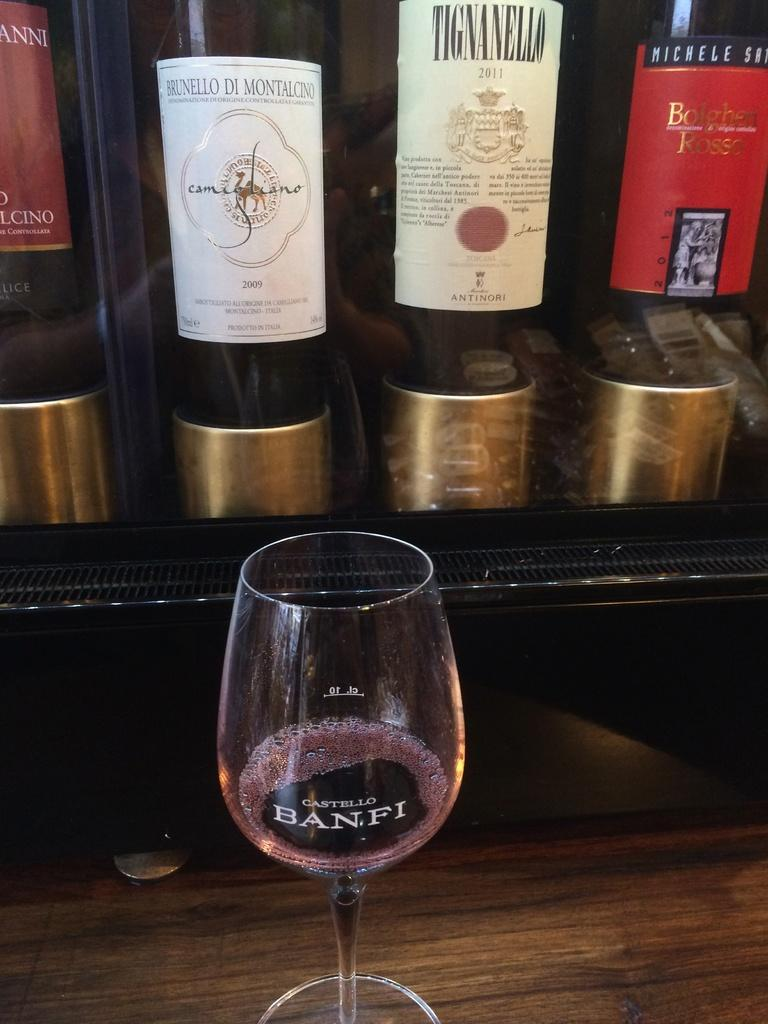<image>
Offer a succinct explanation of the picture presented. Bottles of wine sit behind a glass etched with  Castello Banfi. 